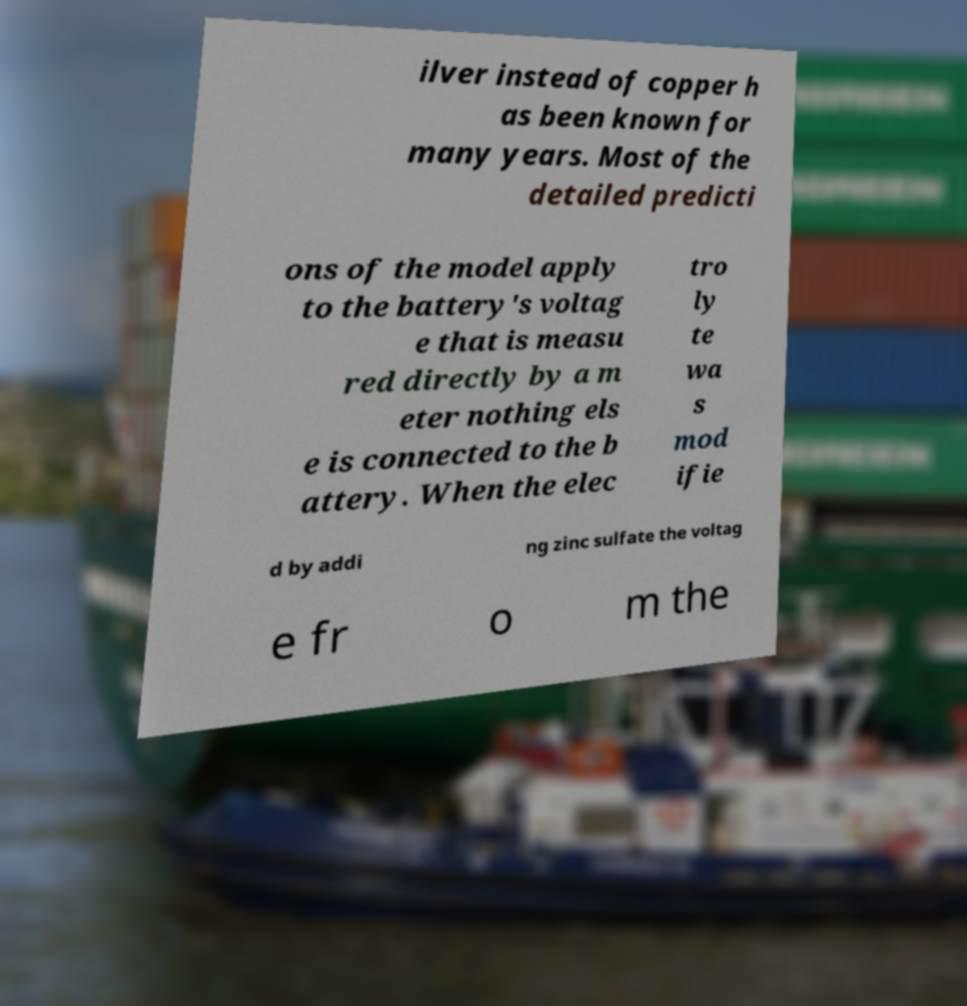Could you assist in decoding the text presented in this image and type it out clearly? ilver instead of copper h as been known for many years. Most of the detailed predicti ons of the model apply to the battery's voltag e that is measu red directly by a m eter nothing els e is connected to the b attery. When the elec tro ly te wa s mod ifie d by addi ng zinc sulfate the voltag e fr o m the 